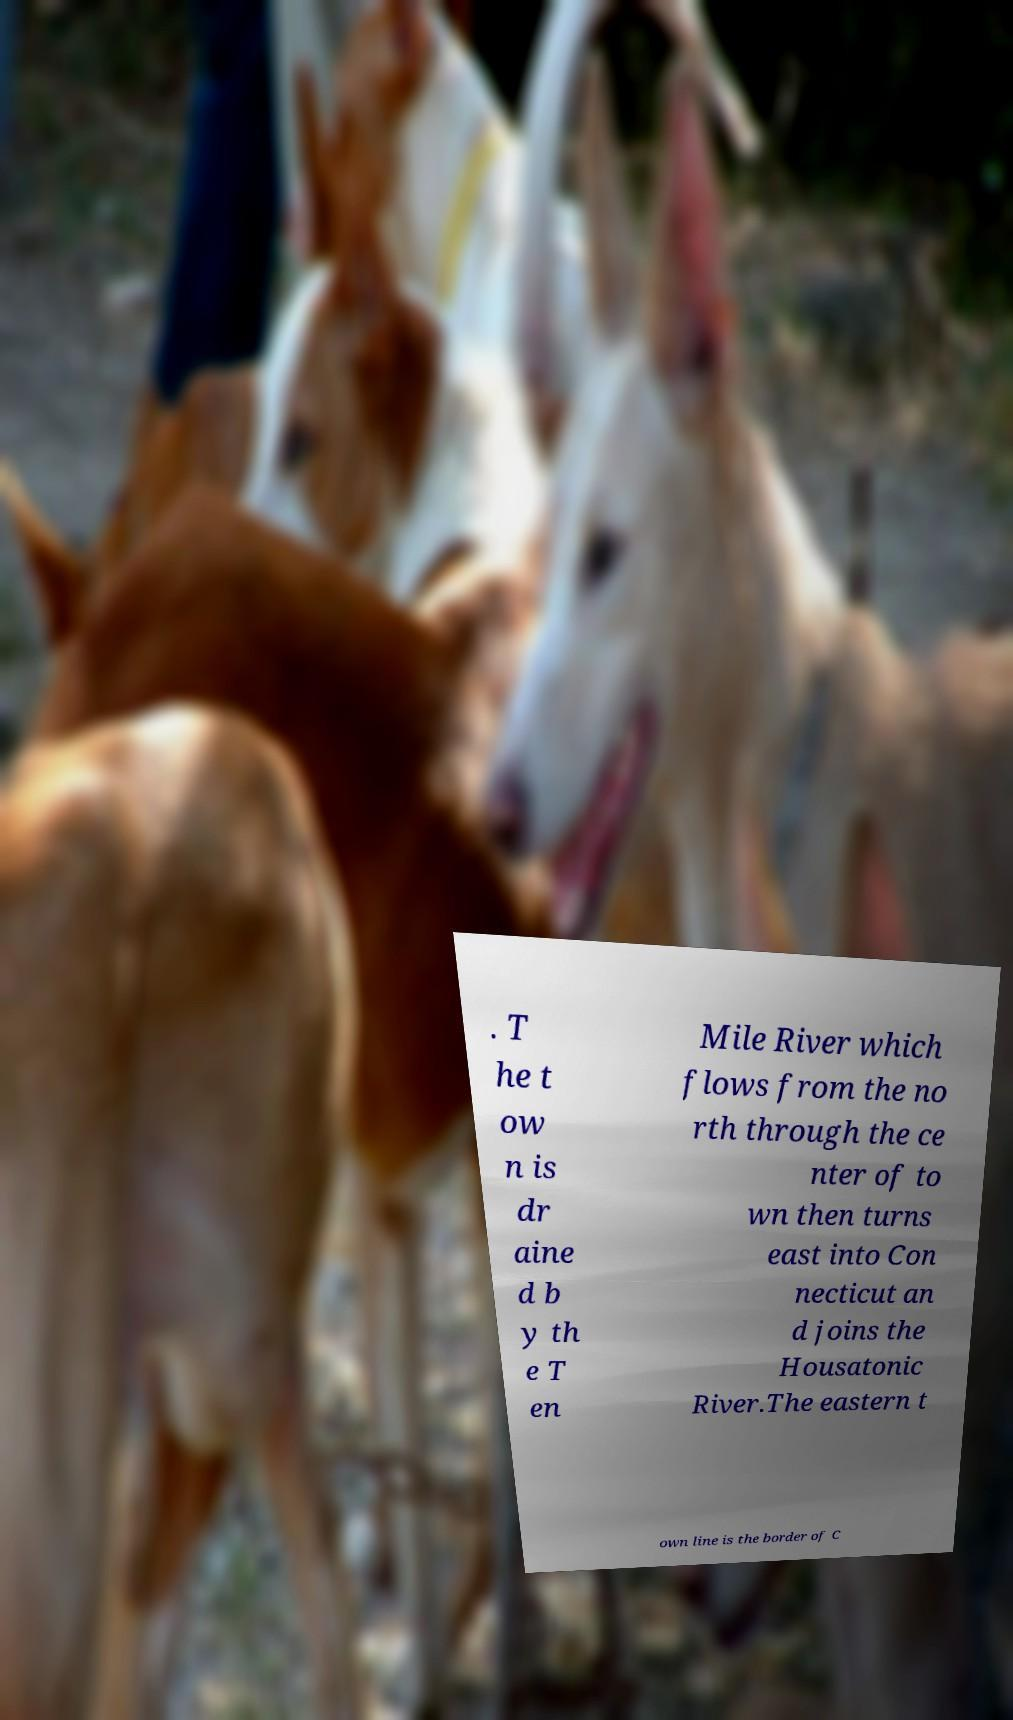Could you extract and type out the text from this image? . T he t ow n is dr aine d b y th e T en Mile River which flows from the no rth through the ce nter of to wn then turns east into Con necticut an d joins the Housatonic River.The eastern t own line is the border of C 